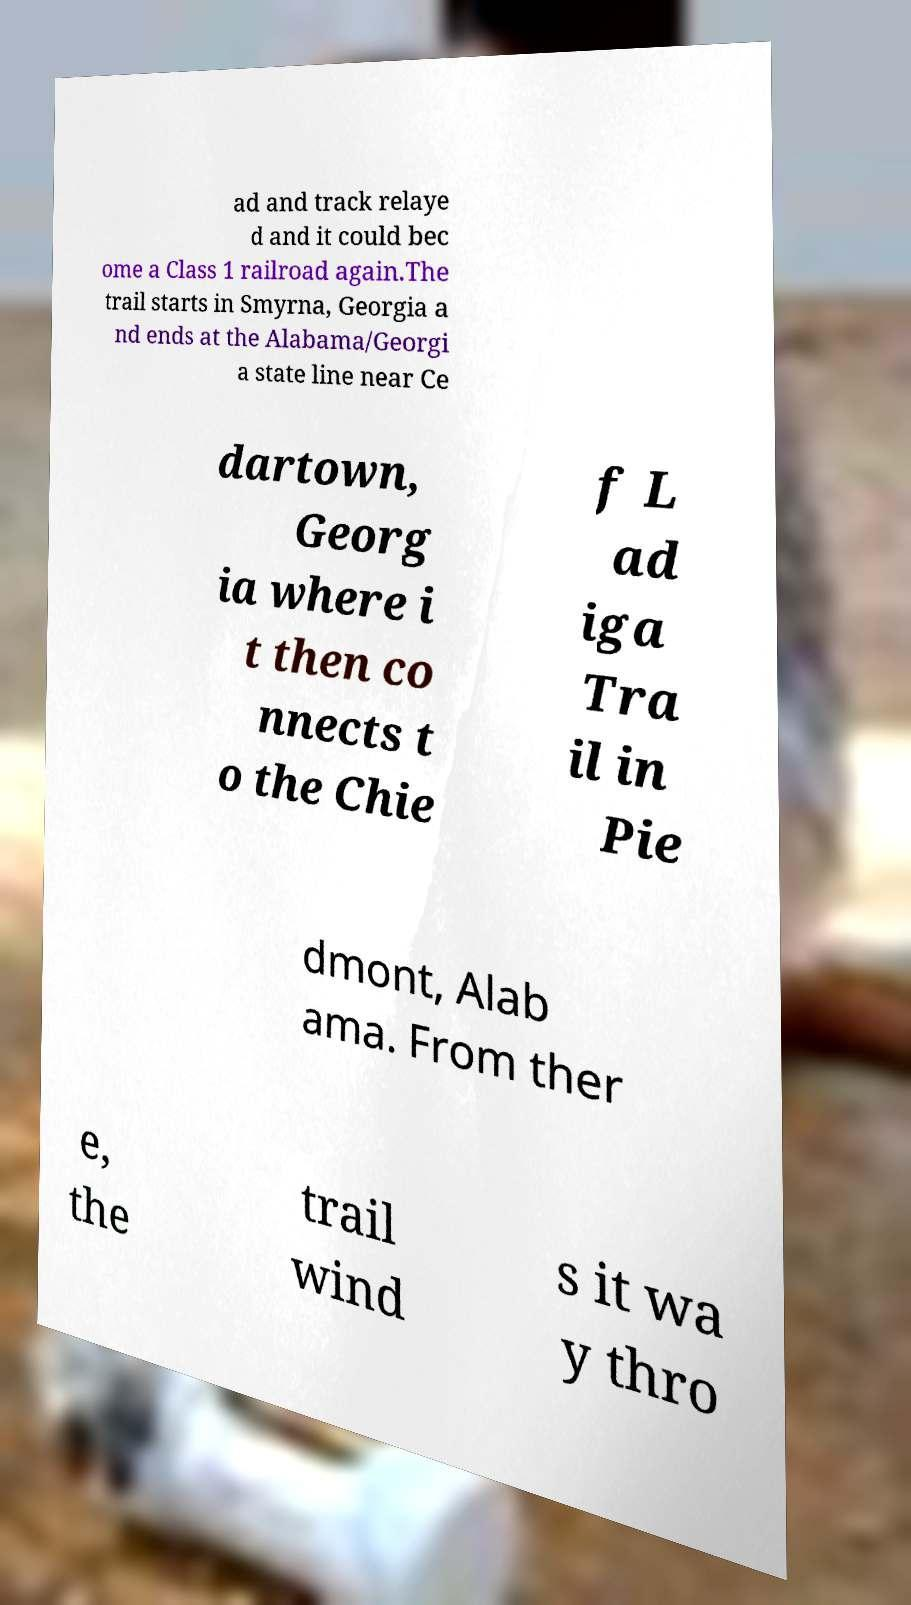Please read and relay the text visible in this image. What does it say? ad and track relaye d and it could bec ome a Class 1 railroad again.The trail starts in Smyrna, Georgia a nd ends at the Alabama/Georgi a state line near Ce dartown, Georg ia where i t then co nnects t o the Chie f L ad iga Tra il in Pie dmont, Alab ama. From ther e, the trail wind s it wa y thro 